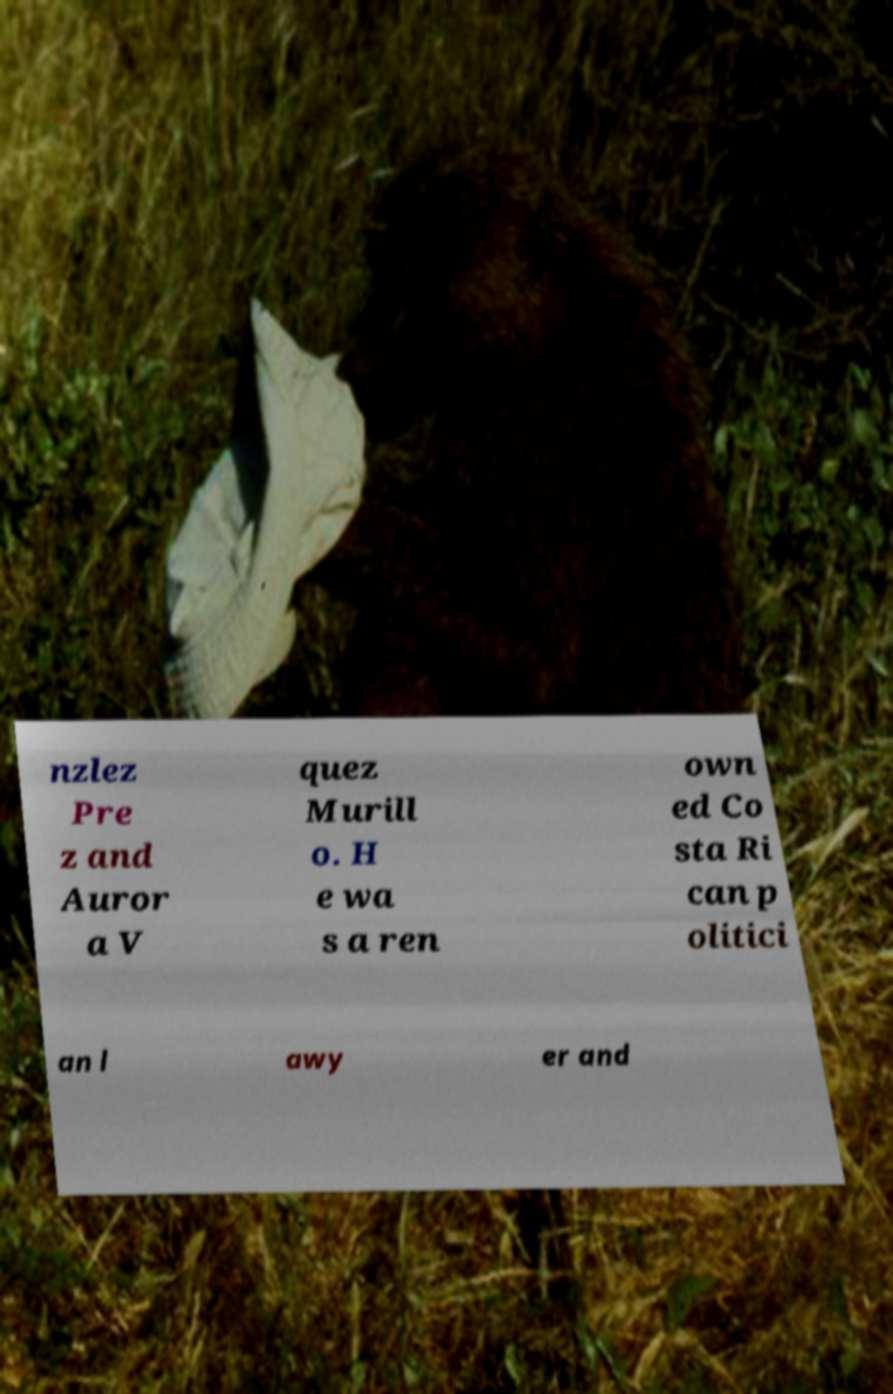For documentation purposes, I need the text within this image transcribed. Could you provide that? nzlez Pre z and Auror a V quez Murill o. H e wa s a ren own ed Co sta Ri can p olitici an l awy er and 